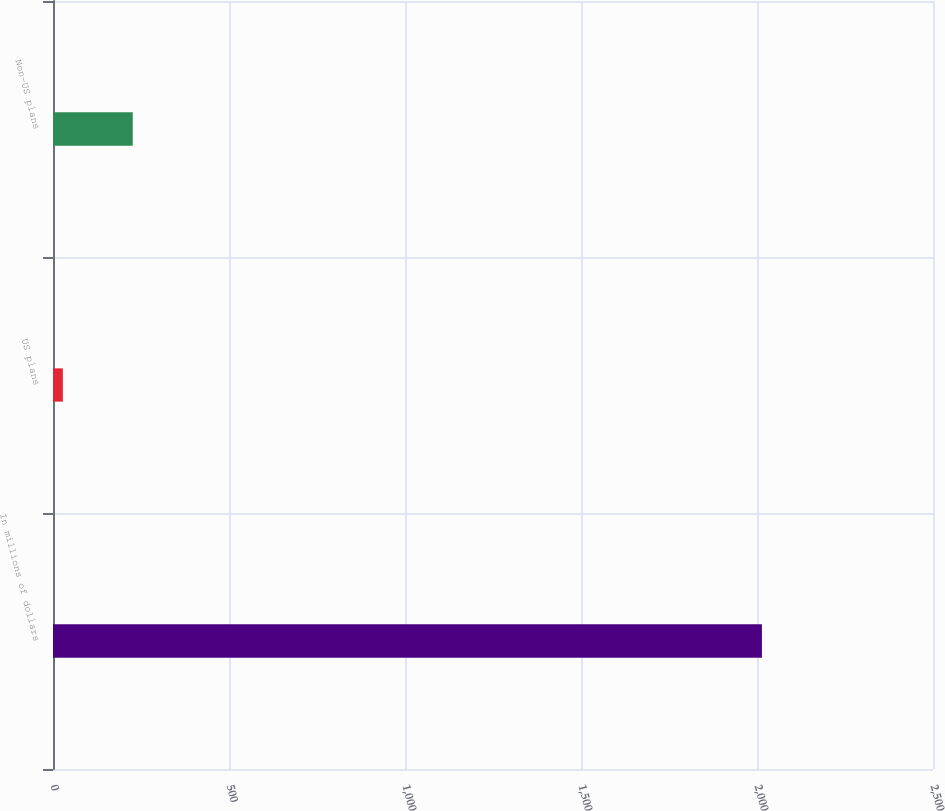<chart> <loc_0><loc_0><loc_500><loc_500><bar_chart><fcel>In millions of dollars<fcel>US plans<fcel>Non-US plans<nl><fcel>2014<fcel>28<fcel>226.6<nl></chart> 